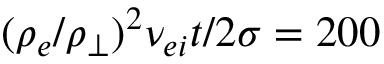Convert formula to latex. <formula><loc_0><loc_0><loc_500><loc_500>( \rho _ { e } / \rho _ { \perp } ) ^ { 2 } \nu _ { e i } t / 2 \sigma = 2 0 0</formula> 